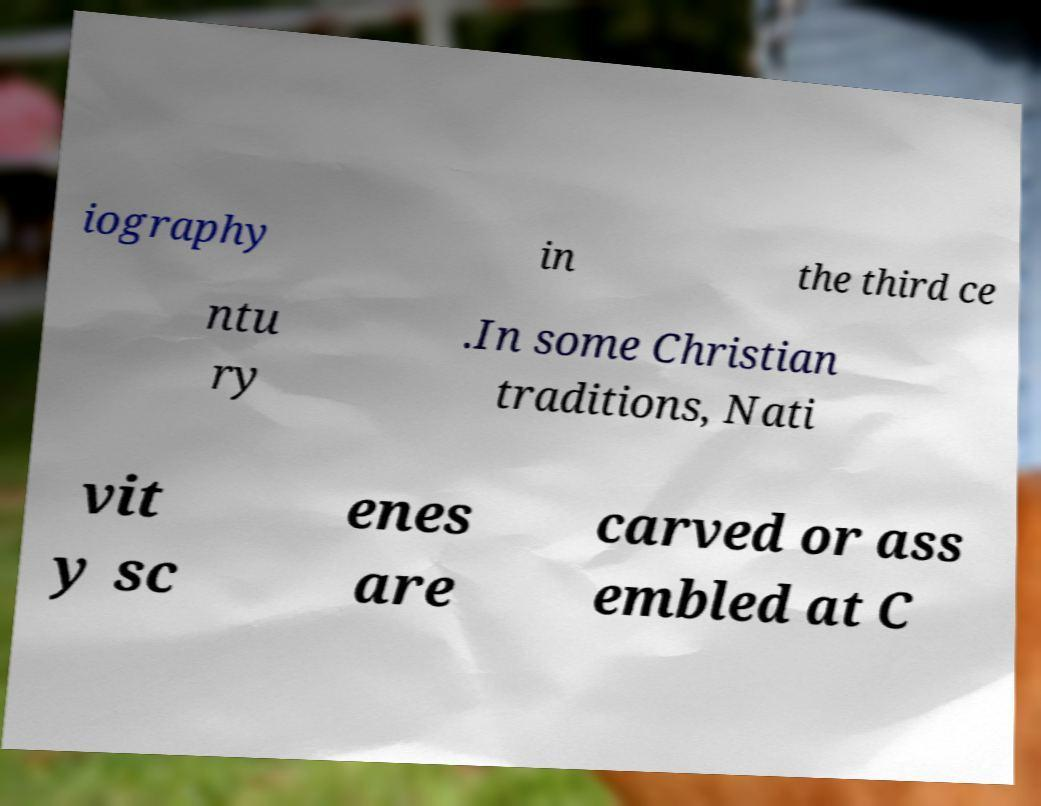Please identify and transcribe the text found in this image. iography in the third ce ntu ry .In some Christian traditions, Nati vit y sc enes are carved or ass embled at C 